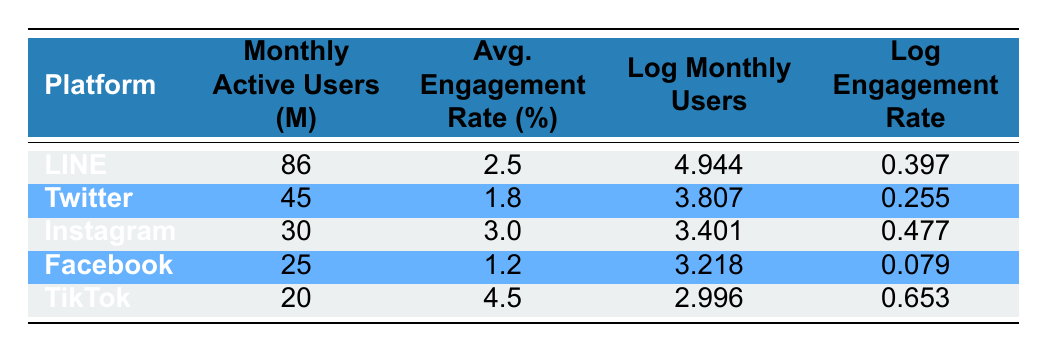What is the average engagement rate for the given social media platforms? To find the average engagement rate, add all the average engagement rates together (2.5 + 1.8 + 3.0 + 1.2 + 4.5 = 13.0) and divide by the number of platforms (5). The average engagement rate is 13.0 / 5 = 2.6.
Answer: 2.6 Which platform has the highest number of monthly active users? By comparing the monthly active users for each platform, LINE has 86 million users, which is greater than the others (45 for Twitter, 30 for Instagram, 25 for Facebook, and 20 for TikTok).
Answer: LINE Is TikTok's average engagement rate higher than Twitter's? TikTok's average engagement rate is 4.5%, while Twitter's is 1.8%. Since 4.5% is greater than 1.8%, the statement is true.
Answer: Yes What is the difference in monthly active users between LINE and Facebook? To find the difference, subtract the number of monthly active users of Facebook (25) from that of LINE (86). The difference is 86 - 25 = 61 million.
Answer: 61 Which platform has a logarithmic value of monthly users closest to 3.5? Comparing the logarithmic values, Instagram (3.401) is the closest to 3.5 while Facebook (3.218) and TikTok (2.996) are farther away, and Twitter (3.807) is slightly over 3.5.
Answer: Instagram Are there any platforms with an engagement rate higher than Facebook? Facebook's engagement rate is 1.2%. Both TikTok (4.5%) and Instagram (3.0%) have engagement rates higher than Facebook's, making the statement true.
Answer: Yes What is the sum of the logarithmic values of monthly users for all platforms? To find the sum of the logarithmic values, add them together: 4.944 (LINE) + 3.807 (Twitter) + 3.401 (Instagram) + 3.218 (Facebook) + 2.996 (TikTok) = 18.366.
Answer: 18.366 Which platform has the lowest log engagement rate and what is that value? Based on the table, Facebook has the lowest log engagement rate of 0.079 compared to the others (0.397 for LINE, 0.255 for Twitter, 0.477 for Instagram, and 0.653 for TikTok).
Answer: 0.079 If you combine the monthly active users of Instagram and TikTok, do they exceed those of Twitter? Instagram has 30 million and TikTok has 20 million, so combining them gives 30 + 20 = 50 million, which is less than Twitter's 45 million. Therefore, they do not exceed Twitter's users.
Answer: No 